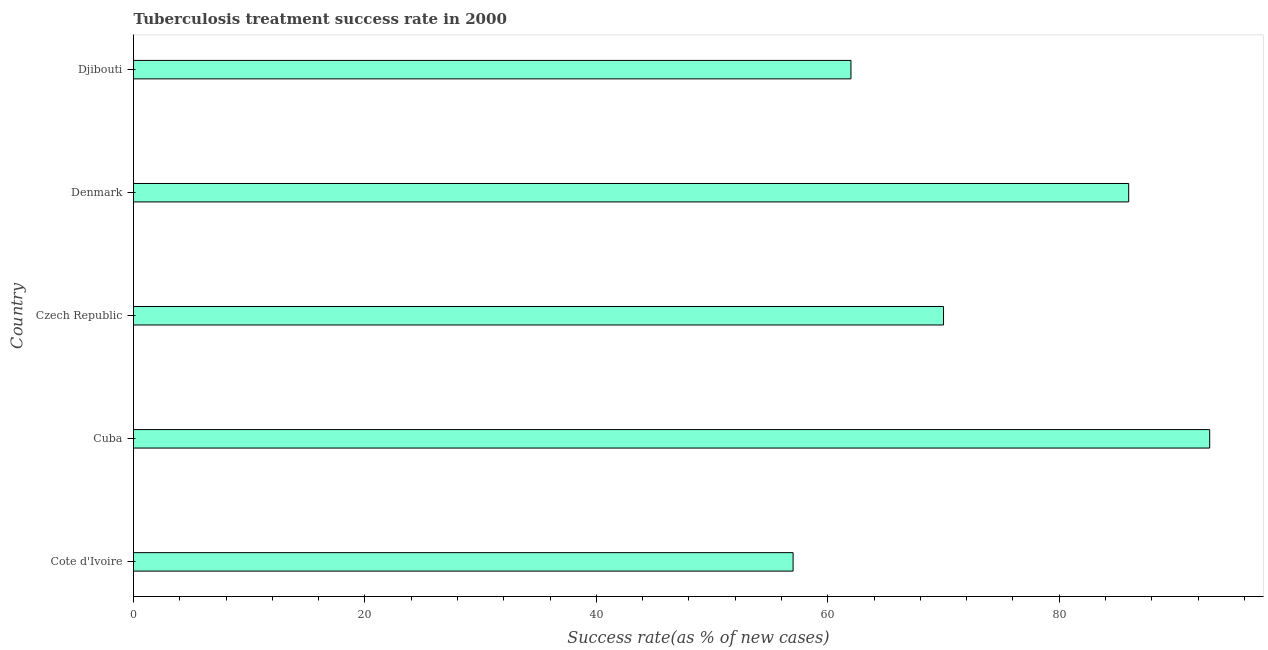What is the title of the graph?
Give a very brief answer. Tuberculosis treatment success rate in 2000. What is the label or title of the X-axis?
Give a very brief answer. Success rate(as % of new cases). What is the tuberculosis treatment success rate in Cuba?
Give a very brief answer. 93. Across all countries, what is the maximum tuberculosis treatment success rate?
Offer a terse response. 93. In which country was the tuberculosis treatment success rate maximum?
Ensure brevity in your answer.  Cuba. In which country was the tuberculosis treatment success rate minimum?
Keep it short and to the point. Cote d'Ivoire. What is the sum of the tuberculosis treatment success rate?
Give a very brief answer. 368. What is the average tuberculosis treatment success rate per country?
Offer a very short reply. 73. What is the median tuberculosis treatment success rate?
Provide a short and direct response. 70. What is the ratio of the tuberculosis treatment success rate in Cote d'Ivoire to that in Denmark?
Keep it short and to the point. 0.66. Is the tuberculosis treatment success rate in Cuba less than that in Denmark?
Provide a succinct answer. No. Is the difference between the tuberculosis treatment success rate in Cote d'Ivoire and Djibouti greater than the difference between any two countries?
Offer a very short reply. No. What is the difference between the highest and the lowest tuberculosis treatment success rate?
Your response must be concise. 36. In how many countries, is the tuberculosis treatment success rate greater than the average tuberculosis treatment success rate taken over all countries?
Provide a succinct answer. 2. How many bars are there?
Give a very brief answer. 5. What is the difference between two consecutive major ticks on the X-axis?
Provide a short and direct response. 20. Are the values on the major ticks of X-axis written in scientific E-notation?
Make the answer very short. No. What is the Success rate(as % of new cases) of Cuba?
Your answer should be very brief. 93. What is the Success rate(as % of new cases) of Denmark?
Give a very brief answer. 86. What is the difference between the Success rate(as % of new cases) in Cote d'Ivoire and Cuba?
Make the answer very short. -36. What is the difference between the Success rate(as % of new cases) in Cuba and Denmark?
Give a very brief answer. 7. What is the difference between the Success rate(as % of new cases) in Cuba and Djibouti?
Ensure brevity in your answer.  31. What is the difference between the Success rate(as % of new cases) in Denmark and Djibouti?
Provide a short and direct response. 24. What is the ratio of the Success rate(as % of new cases) in Cote d'Ivoire to that in Cuba?
Your response must be concise. 0.61. What is the ratio of the Success rate(as % of new cases) in Cote d'Ivoire to that in Czech Republic?
Give a very brief answer. 0.81. What is the ratio of the Success rate(as % of new cases) in Cote d'Ivoire to that in Denmark?
Your answer should be compact. 0.66. What is the ratio of the Success rate(as % of new cases) in Cote d'Ivoire to that in Djibouti?
Provide a short and direct response. 0.92. What is the ratio of the Success rate(as % of new cases) in Cuba to that in Czech Republic?
Your answer should be very brief. 1.33. What is the ratio of the Success rate(as % of new cases) in Cuba to that in Denmark?
Provide a short and direct response. 1.08. What is the ratio of the Success rate(as % of new cases) in Czech Republic to that in Denmark?
Offer a very short reply. 0.81. What is the ratio of the Success rate(as % of new cases) in Czech Republic to that in Djibouti?
Your answer should be very brief. 1.13. What is the ratio of the Success rate(as % of new cases) in Denmark to that in Djibouti?
Offer a terse response. 1.39. 